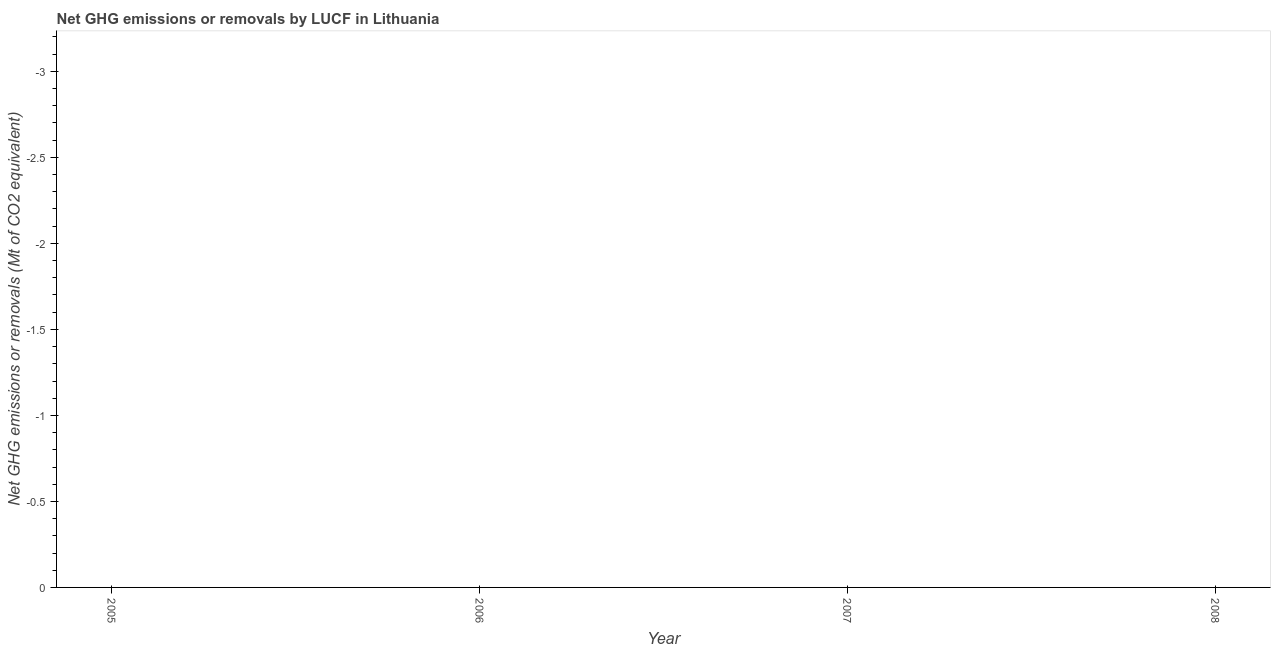What is the ghg net emissions or removals in 2008?
Ensure brevity in your answer.  0. Across all years, what is the minimum ghg net emissions or removals?
Provide a short and direct response. 0. What is the average ghg net emissions or removals per year?
Provide a short and direct response. 0. What is the median ghg net emissions or removals?
Give a very brief answer. 0. In how many years, is the ghg net emissions or removals greater than the average ghg net emissions or removals taken over all years?
Offer a very short reply. 0. Does the ghg net emissions or removals monotonically increase over the years?
Your answer should be compact. No. How many years are there in the graph?
Provide a succinct answer. 4. What is the difference between two consecutive major ticks on the Y-axis?
Offer a very short reply. 0.5. Are the values on the major ticks of Y-axis written in scientific E-notation?
Ensure brevity in your answer.  No. Does the graph contain any zero values?
Provide a succinct answer. Yes. Does the graph contain grids?
Your answer should be compact. No. What is the title of the graph?
Your answer should be compact. Net GHG emissions or removals by LUCF in Lithuania. What is the label or title of the Y-axis?
Your answer should be very brief. Net GHG emissions or removals (Mt of CO2 equivalent). What is the Net GHG emissions or removals (Mt of CO2 equivalent) of 2005?
Give a very brief answer. 0. 